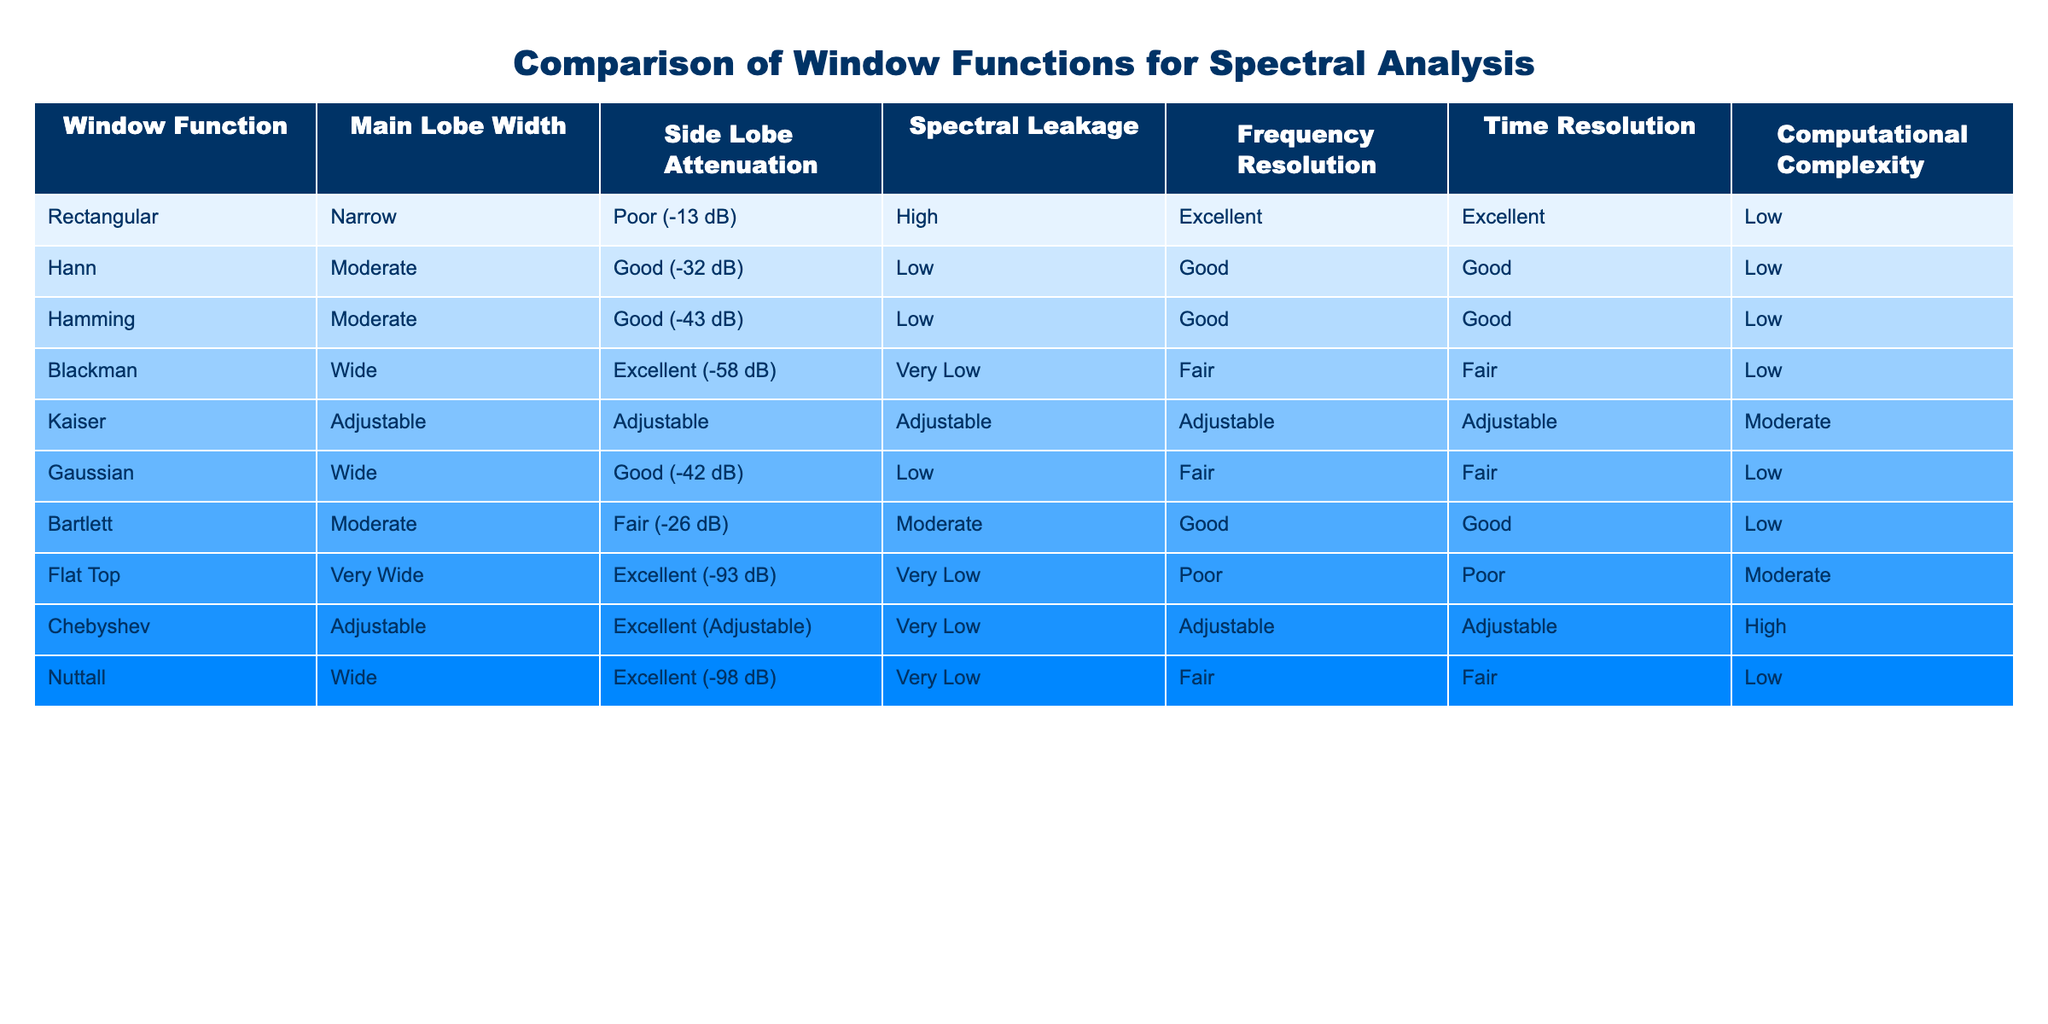What is the side lobe attenuation of the Hamming window function? Referring to the table, the Hamming window function has a side lobe attenuation of Good (-43 dB).
Answer: Good (-43 dB) Which window functions have excellent side lobe attenuation? By checking the "Side Lobe Attenuation" column, the window functions with excellent side lobe attenuation are Blackman, Chebyshev, and Nuttall.
Answer: Blackman, Chebyshev, Nuttall What is the frequency resolution for the Flat Top window function? Looking at the table, the Flat Top window function has a frequency resolution indicated as Poor.
Answer: Poor Which window function has the highest side lobe attenuation value? The table indicates that the Flat Top window function has the highest side lobe attenuation value of Excellent (-93 dB). We can ascertain this by comparing the values in the "Side Lobe Attenuation" column.
Answer: Excellent (-93 dB) What is the average main lobe width among the wide window functions? From the table, the window functions classified as wide are Blackman, Gaussian, Nuttall. The main lobe widths for these functions are wide, wide, and wide respectively. Since they are all the same, the average main lobe width is also wide.
Answer: Wide Is it true that the Kaiser window function provides low computational complexity? Looking at the table, the Kaiser window function has a computational complexity marked as Moderate, which means it does not provide low complexity. Therefore, the statement is false.
Answer: No Which window functions have good time resolution? In the "Time Resolution" column, the window functions that have good time resolution are Hann, Hamming, Bartlett. This can be derived by reviewing the respective values in that column.
Answer: Hann, Hamming, Bartlett If we compare the rectangular and the Bartlett window functions in terms of spectral leakage, which one has lower spectral leakage? The rectangular window function is classified as having High spectral leakage, while the Bartlett window function is classified as having Moderate spectral leakage. Since Moderate is better than High, the Bartlett window has lower spectral leakage compared to the rectangular window.
Answer: Bartlett What is the computational complexity of the Chebyshev window function? By checking the table, the computational complexity of the Chebyshev window function is classified as High.
Answer: High 